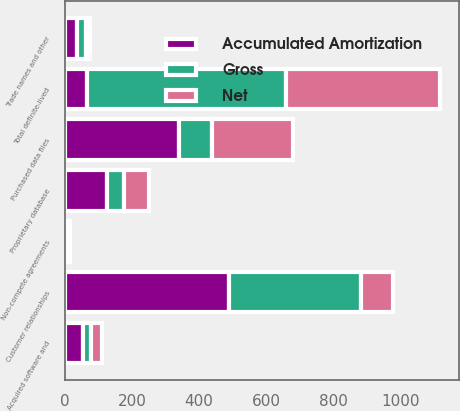Convert chart to OTSL. <chart><loc_0><loc_0><loc_500><loc_500><stacked_bar_chart><ecel><fcel>Purchased data files<fcel>Acquired software and<fcel>Customer relationships<fcel>Proprietary database<fcel>Non-compete agreements<fcel>Trade names and other<fcel>Total definite-lived<nl><fcel>Accumulated Amortization<fcel>339.2<fcel>55<fcel>489.2<fcel>125<fcel>7.2<fcel>37.4<fcel>64.7<nl><fcel>Net<fcel>240.7<fcel>33.3<fcel>97.1<fcel>74.4<fcel>1.4<fcel>12.2<fcel>459.1<nl><fcel>Gross<fcel>98.5<fcel>21.7<fcel>392.1<fcel>50.6<fcel>5.8<fcel>25.2<fcel>593.9<nl></chart> 